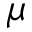<formula> <loc_0><loc_0><loc_500><loc_500>\mu</formula> 